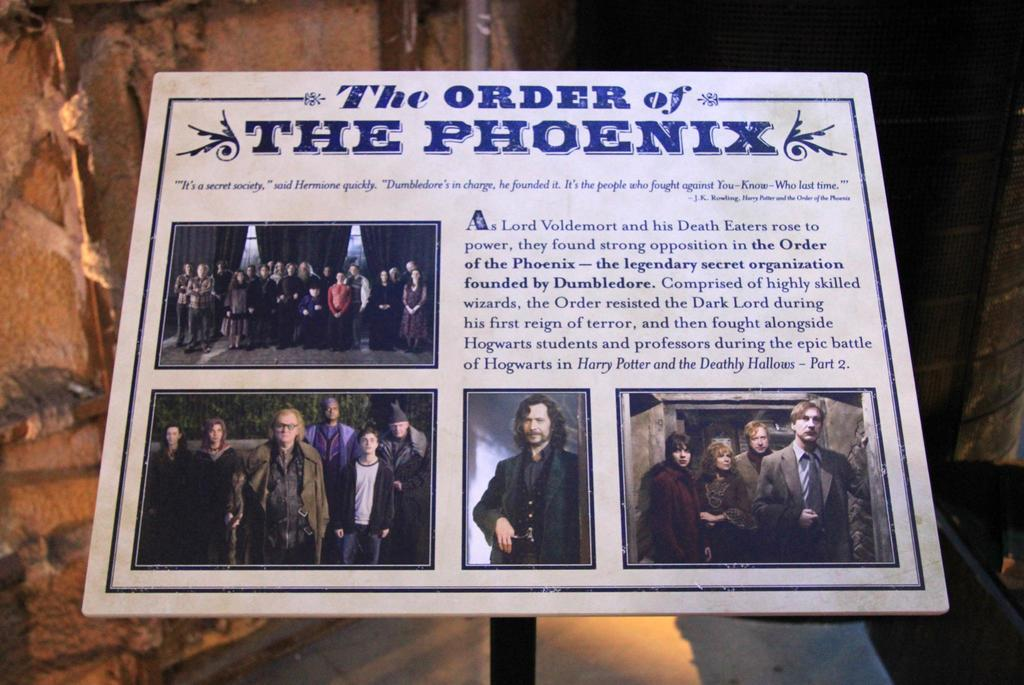<image>
Share a concise interpretation of the image provided. A poster for the order of the Phoenix with the characters at the bottom. 